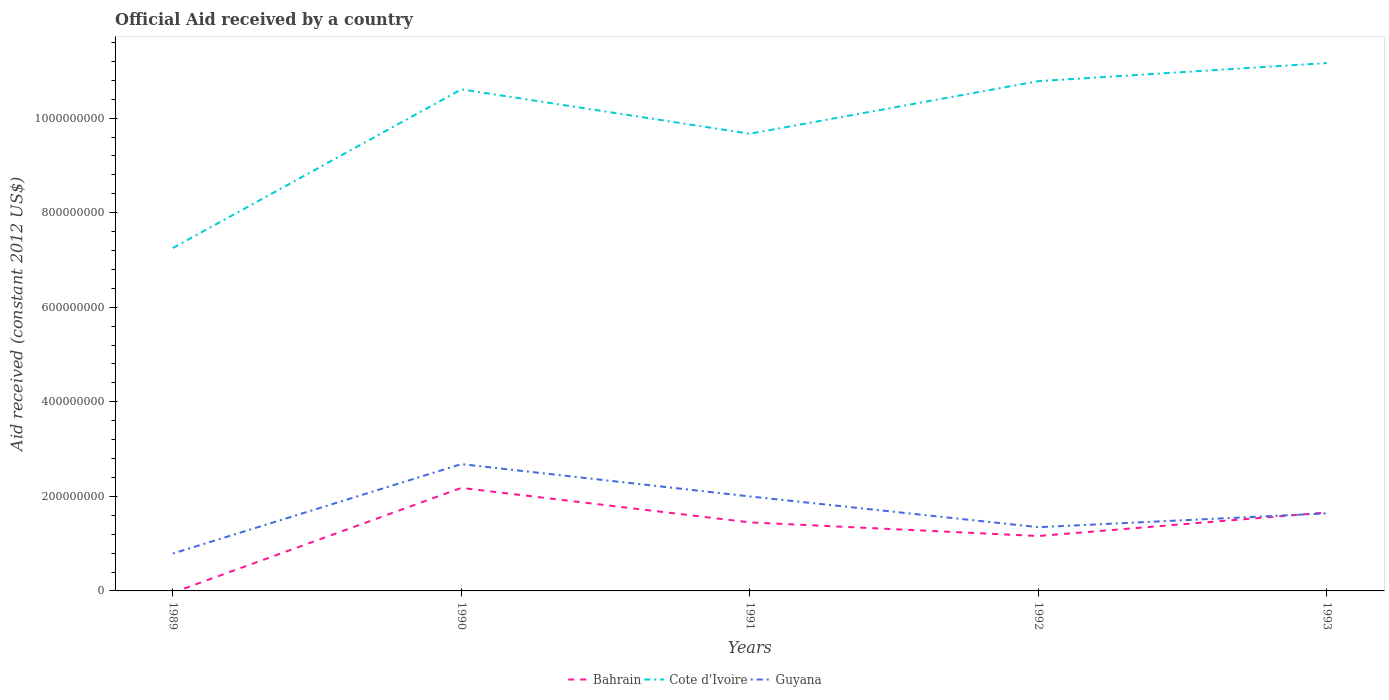How many different coloured lines are there?
Make the answer very short. 3. What is the total net official aid received in Cote d'Ivoire in the graph?
Your answer should be very brief. -5.56e+07. What is the difference between the highest and the second highest net official aid received in Cote d'Ivoire?
Offer a terse response. 3.91e+08. What is the difference between the highest and the lowest net official aid received in Cote d'Ivoire?
Keep it short and to the point. 3. How many years are there in the graph?
Provide a short and direct response. 5. Does the graph contain any zero values?
Offer a terse response. Yes. Where does the legend appear in the graph?
Your answer should be compact. Bottom center. How many legend labels are there?
Your answer should be very brief. 3. What is the title of the graph?
Your answer should be compact. Official Aid received by a country. What is the label or title of the X-axis?
Your answer should be compact. Years. What is the label or title of the Y-axis?
Your answer should be compact. Aid received (constant 2012 US$). What is the Aid received (constant 2012 US$) in Cote d'Ivoire in 1989?
Your answer should be very brief. 7.25e+08. What is the Aid received (constant 2012 US$) in Guyana in 1989?
Your answer should be very brief. 7.91e+07. What is the Aid received (constant 2012 US$) in Bahrain in 1990?
Keep it short and to the point. 2.18e+08. What is the Aid received (constant 2012 US$) in Cote d'Ivoire in 1990?
Your answer should be very brief. 1.06e+09. What is the Aid received (constant 2012 US$) of Guyana in 1990?
Give a very brief answer. 2.68e+08. What is the Aid received (constant 2012 US$) of Bahrain in 1991?
Offer a very short reply. 1.45e+08. What is the Aid received (constant 2012 US$) of Cote d'Ivoire in 1991?
Keep it short and to the point. 9.67e+08. What is the Aid received (constant 2012 US$) in Guyana in 1991?
Your response must be concise. 2.00e+08. What is the Aid received (constant 2012 US$) in Bahrain in 1992?
Provide a succinct answer. 1.16e+08. What is the Aid received (constant 2012 US$) of Cote d'Ivoire in 1992?
Keep it short and to the point. 1.08e+09. What is the Aid received (constant 2012 US$) of Guyana in 1992?
Your answer should be compact. 1.35e+08. What is the Aid received (constant 2012 US$) in Bahrain in 1993?
Offer a very short reply. 1.66e+08. What is the Aid received (constant 2012 US$) of Cote d'Ivoire in 1993?
Ensure brevity in your answer.  1.12e+09. What is the Aid received (constant 2012 US$) of Guyana in 1993?
Keep it short and to the point. 1.64e+08. Across all years, what is the maximum Aid received (constant 2012 US$) in Bahrain?
Provide a succinct answer. 2.18e+08. Across all years, what is the maximum Aid received (constant 2012 US$) of Cote d'Ivoire?
Offer a terse response. 1.12e+09. Across all years, what is the maximum Aid received (constant 2012 US$) of Guyana?
Provide a succinct answer. 2.68e+08. Across all years, what is the minimum Aid received (constant 2012 US$) in Cote d'Ivoire?
Your response must be concise. 7.25e+08. Across all years, what is the minimum Aid received (constant 2012 US$) in Guyana?
Offer a very short reply. 7.91e+07. What is the total Aid received (constant 2012 US$) of Bahrain in the graph?
Offer a terse response. 6.45e+08. What is the total Aid received (constant 2012 US$) of Cote d'Ivoire in the graph?
Provide a short and direct response. 4.95e+09. What is the total Aid received (constant 2012 US$) of Guyana in the graph?
Provide a short and direct response. 8.46e+08. What is the difference between the Aid received (constant 2012 US$) in Cote d'Ivoire in 1989 and that in 1990?
Give a very brief answer. -3.36e+08. What is the difference between the Aid received (constant 2012 US$) of Guyana in 1989 and that in 1990?
Keep it short and to the point. -1.89e+08. What is the difference between the Aid received (constant 2012 US$) of Cote d'Ivoire in 1989 and that in 1991?
Offer a very short reply. -2.42e+08. What is the difference between the Aid received (constant 2012 US$) of Guyana in 1989 and that in 1991?
Your response must be concise. -1.21e+08. What is the difference between the Aid received (constant 2012 US$) of Cote d'Ivoire in 1989 and that in 1992?
Your response must be concise. -3.53e+08. What is the difference between the Aid received (constant 2012 US$) in Guyana in 1989 and that in 1992?
Your response must be concise. -5.57e+07. What is the difference between the Aid received (constant 2012 US$) in Cote d'Ivoire in 1989 and that in 1993?
Provide a short and direct response. -3.91e+08. What is the difference between the Aid received (constant 2012 US$) of Guyana in 1989 and that in 1993?
Your answer should be compact. -8.49e+07. What is the difference between the Aid received (constant 2012 US$) in Bahrain in 1990 and that in 1991?
Offer a terse response. 7.29e+07. What is the difference between the Aid received (constant 2012 US$) of Cote d'Ivoire in 1990 and that in 1991?
Make the answer very short. 9.38e+07. What is the difference between the Aid received (constant 2012 US$) in Guyana in 1990 and that in 1991?
Your response must be concise. 6.84e+07. What is the difference between the Aid received (constant 2012 US$) in Bahrain in 1990 and that in 1992?
Your answer should be very brief. 1.02e+08. What is the difference between the Aid received (constant 2012 US$) of Cote d'Ivoire in 1990 and that in 1992?
Your response must be concise. -1.74e+07. What is the difference between the Aid received (constant 2012 US$) in Guyana in 1990 and that in 1992?
Your answer should be very brief. 1.33e+08. What is the difference between the Aid received (constant 2012 US$) in Bahrain in 1990 and that in 1993?
Ensure brevity in your answer.  5.20e+07. What is the difference between the Aid received (constant 2012 US$) in Cote d'Ivoire in 1990 and that in 1993?
Make the answer very short. -5.56e+07. What is the difference between the Aid received (constant 2012 US$) of Guyana in 1990 and that in 1993?
Offer a very short reply. 1.04e+08. What is the difference between the Aid received (constant 2012 US$) in Bahrain in 1991 and that in 1992?
Keep it short and to the point. 2.89e+07. What is the difference between the Aid received (constant 2012 US$) in Cote d'Ivoire in 1991 and that in 1992?
Ensure brevity in your answer.  -1.11e+08. What is the difference between the Aid received (constant 2012 US$) in Guyana in 1991 and that in 1992?
Keep it short and to the point. 6.50e+07. What is the difference between the Aid received (constant 2012 US$) of Bahrain in 1991 and that in 1993?
Your answer should be very brief. -2.10e+07. What is the difference between the Aid received (constant 2012 US$) of Cote d'Ivoire in 1991 and that in 1993?
Make the answer very short. -1.49e+08. What is the difference between the Aid received (constant 2012 US$) of Guyana in 1991 and that in 1993?
Make the answer very short. 3.58e+07. What is the difference between the Aid received (constant 2012 US$) of Bahrain in 1992 and that in 1993?
Make the answer very short. -4.98e+07. What is the difference between the Aid received (constant 2012 US$) of Cote d'Ivoire in 1992 and that in 1993?
Your answer should be very brief. -3.83e+07. What is the difference between the Aid received (constant 2012 US$) in Guyana in 1992 and that in 1993?
Your answer should be compact. -2.92e+07. What is the difference between the Aid received (constant 2012 US$) of Cote d'Ivoire in 1989 and the Aid received (constant 2012 US$) of Guyana in 1990?
Give a very brief answer. 4.57e+08. What is the difference between the Aid received (constant 2012 US$) in Cote d'Ivoire in 1989 and the Aid received (constant 2012 US$) in Guyana in 1991?
Your response must be concise. 5.26e+08. What is the difference between the Aid received (constant 2012 US$) of Cote d'Ivoire in 1989 and the Aid received (constant 2012 US$) of Guyana in 1992?
Keep it short and to the point. 5.91e+08. What is the difference between the Aid received (constant 2012 US$) of Cote d'Ivoire in 1989 and the Aid received (constant 2012 US$) of Guyana in 1993?
Give a very brief answer. 5.61e+08. What is the difference between the Aid received (constant 2012 US$) of Bahrain in 1990 and the Aid received (constant 2012 US$) of Cote d'Ivoire in 1991?
Ensure brevity in your answer.  -7.49e+08. What is the difference between the Aid received (constant 2012 US$) in Bahrain in 1990 and the Aid received (constant 2012 US$) in Guyana in 1991?
Ensure brevity in your answer.  1.81e+07. What is the difference between the Aid received (constant 2012 US$) of Cote d'Ivoire in 1990 and the Aid received (constant 2012 US$) of Guyana in 1991?
Give a very brief answer. 8.61e+08. What is the difference between the Aid received (constant 2012 US$) of Bahrain in 1990 and the Aid received (constant 2012 US$) of Cote d'Ivoire in 1992?
Provide a short and direct response. -8.60e+08. What is the difference between the Aid received (constant 2012 US$) in Bahrain in 1990 and the Aid received (constant 2012 US$) in Guyana in 1992?
Your answer should be compact. 8.31e+07. What is the difference between the Aid received (constant 2012 US$) in Cote d'Ivoire in 1990 and the Aid received (constant 2012 US$) in Guyana in 1992?
Give a very brief answer. 9.26e+08. What is the difference between the Aid received (constant 2012 US$) of Bahrain in 1990 and the Aid received (constant 2012 US$) of Cote d'Ivoire in 1993?
Provide a short and direct response. -8.99e+08. What is the difference between the Aid received (constant 2012 US$) in Bahrain in 1990 and the Aid received (constant 2012 US$) in Guyana in 1993?
Your response must be concise. 5.38e+07. What is the difference between the Aid received (constant 2012 US$) in Cote d'Ivoire in 1990 and the Aid received (constant 2012 US$) in Guyana in 1993?
Offer a terse response. 8.97e+08. What is the difference between the Aid received (constant 2012 US$) in Bahrain in 1991 and the Aid received (constant 2012 US$) in Cote d'Ivoire in 1992?
Offer a terse response. -9.33e+08. What is the difference between the Aid received (constant 2012 US$) of Bahrain in 1991 and the Aid received (constant 2012 US$) of Guyana in 1992?
Ensure brevity in your answer.  1.02e+07. What is the difference between the Aid received (constant 2012 US$) in Cote d'Ivoire in 1991 and the Aid received (constant 2012 US$) in Guyana in 1992?
Your answer should be very brief. 8.32e+08. What is the difference between the Aid received (constant 2012 US$) in Bahrain in 1991 and the Aid received (constant 2012 US$) in Cote d'Ivoire in 1993?
Provide a short and direct response. -9.72e+08. What is the difference between the Aid received (constant 2012 US$) in Bahrain in 1991 and the Aid received (constant 2012 US$) in Guyana in 1993?
Offer a terse response. -1.90e+07. What is the difference between the Aid received (constant 2012 US$) of Cote d'Ivoire in 1991 and the Aid received (constant 2012 US$) of Guyana in 1993?
Provide a short and direct response. 8.03e+08. What is the difference between the Aid received (constant 2012 US$) of Bahrain in 1992 and the Aid received (constant 2012 US$) of Cote d'Ivoire in 1993?
Offer a very short reply. -1.00e+09. What is the difference between the Aid received (constant 2012 US$) in Bahrain in 1992 and the Aid received (constant 2012 US$) in Guyana in 1993?
Offer a very short reply. -4.79e+07. What is the difference between the Aid received (constant 2012 US$) of Cote d'Ivoire in 1992 and the Aid received (constant 2012 US$) of Guyana in 1993?
Keep it short and to the point. 9.14e+08. What is the average Aid received (constant 2012 US$) in Bahrain per year?
Provide a succinct answer. 1.29e+08. What is the average Aid received (constant 2012 US$) of Cote d'Ivoire per year?
Your answer should be compact. 9.90e+08. What is the average Aid received (constant 2012 US$) in Guyana per year?
Ensure brevity in your answer.  1.69e+08. In the year 1989, what is the difference between the Aid received (constant 2012 US$) in Cote d'Ivoire and Aid received (constant 2012 US$) in Guyana?
Your answer should be very brief. 6.46e+08. In the year 1990, what is the difference between the Aid received (constant 2012 US$) in Bahrain and Aid received (constant 2012 US$) in Cote d'Ivoire?
Keep it short and to the point. -8.43e+08. In the year 1990, what is the difference between the Aid received (constant 2012 US$) of Bahrain and Aid received (constant 2012 US$) of Guyana?
Keep it short and to the point. -5.03e+07. In the year 1990, what is the difference between the Aid received (constant 2012 US$) in Cote d'Ivoire and Aid received (constant 2012 US$) in Guyana?
Your response must be concise. 7.93e+08. In the year 1991, what is the difference between the Aid received (constant 2012 US$) in Bahrain and Aid received (constant 2012 US$) in Cote d'Ivoire?
Your answer should be very brief. -8.22e+08. In the year 1991, what is the difference between the Aid received (constant 2012 US$) in Bahrain and Aid received (constant 2012 US$) in Guyana?
Your response must be concise. -5.48e+07. In the year 1991, what is the difference between the Aid received (constant 2012 US$) in Cote d'Ivoire and Aid received (constant 2012 US$) in Guyana?
Give a very brief answer. 7.67e+08. In the year 1992, what is the difference between the Aid received (constant 2012 US$) in Bahrain and Aid received (constant 2012 US$) in Cote d'Ivoire?
Ensure brevity in your answer.  -9.62e+08. In the year 1992, what is the difference between the Aid received (constant 2012 US$) in Bahrain and Aid received (constant 2012 US$) in Guyana?
Your answer should be compact. -1.87e+07. In the year 1992, what is the difference between the Aid received (constant 2012 US$) of Cote d'Ivoire and Aid received (constant 2012 US$) of Guyana?
Provide a succinct answer. 9.43e+08. In the year 1993, what is the difference between the Aid received (constant 2012 US$) in Bahrain and Aid received (constant 2012 US$) in Cote d'Ivoire?
Make the answer very short. -9.51e+08. In the year 1993, what is the difference between the Aid received (constant 2012 US$) in Bahrain and Aid received (constant 2012 US$) in Guyana?
Make the answer very short. 1.90e+06. In the year 1993, what is the difference between the Aid received (constant 2012 US$) of Cote d'Ivoire and Aid received (constant 2012 US$) of Guyana?
Keep it short and to the point. 9.52e+08. What is the ratio of the Aid received (constant 2012 US$) of Cote d'Ivoire in 1989 to that in 1990?
Offer a very short reply. 0.68. What is the ratio of the Aid received (constant 2012 US$) of Guyana in 1989 to that in 1990?
Your response must be concise. 0.29. What is the ratio of the Aid received (constant 2012 US$) in Cote d'Ivoire in 1989 to that in 1991?
Provide a succinct answer. 0.75. What is the ratio of the Aid received (constant 2012 US$) in Guyana in 1989 to that in 1991?
Offer a terse response. 0.4. What is the ratio of the Aid received (constant 2012 US$) in Cote d'Ivoire in 1989 to that in 1992?
Your answer should be very brief. 0.67. What is the ratio of the Aid received (constant 2012 US$) of Guyana in 1989 to that in 1992?
Ensure brevity in your answer.  0.59. What is the ratio of the Aid received (constant 2012 US$) of Cote d'Ivoire in 1989 to that in 1993?
Provide a succinct answer. 0.65. What is the ratio of the Aid received (constant 2012 US$) in Guyana in 1989 to that in 1993?
Ensure brevity in your answer.  0.48. What is the ratio of the Aid received (constant 2012 US$) of Bahrain in 1990 to that in 1991?
Ensure brevity in your answer.  1.5. What is the ratio of the Aid received (constant 2012 US$) of Cote d'Ivoire in 1990 to that in 1991?
Your answer should be compact. 1.1. What is the ratio of the Aid received (constant 2012 US$) in Guyana in 1990 to that in 1991?
Give a very brief answer. 1.34. What is the ratio of the Aid received (constant 2012 US$) of Bahrain in 1990 to that in 1992?
Your answer should be compact. 1.88. What is the ratio of the Aid received (constant 2012 US$) in Cote d'Ivoire in 1990 to that in 1992?
Your answer should be very brief. 0.98. What is the ratio of the Aid received (constant 2012 US$) of Guyana in 1990 to that in 1992?
Provide a succinct answer. 1.99. What is the ratio of the Aid received (constant 2012 US$) in Bahrain in 1990 to that in 1993?
Make the answer very short. 1.31. What is the ratio of the Aid received (constant 2012 US$) of Cote d'Ivoire in 1990 to that in 1993?
Your answer should be compact. 0.95. What is the ratio of the Aid received (constant 2012 US$) in Guyana in 1990 to that in 1993?
Offer a terse response. 1.64. What is the ratio of the Aid received (constant 2012 US$) of Bahrain in 1991 to that in 1992?
Your answer should be very brief. 1.25. What is the ratio of the Aid received (constant 2012 US$) of Cote d'Ivoire in 1991 to that in 1992?
Offer a very short reply. 0.9. What is the ratio of the Aid received (constant 2012 US$) of Guyana in 1991 to that in 1992?
Ensure brevity in your answer.  1.48. What is the ratio of the Aid received (constant 2012 US$) in Bahrain in 1991 to that in 1993?
Offer a terse response. 0.87. What is the ratio of the Aid received (constant 2012 US$) in Cote d'Ivoire in 1991 to that in 1993?
Provide a short and direct response. 0.87. What is the ratio of the Aid received (constant 2012 US$) in Guyana in 1991 to that in 1993?
Your answer should be compact. 1.22. What is the ratio of the Aid received (constant 2012 US$) of Bahrain in 1992 to that in 1993?
Your answer should be very brief. 0.7. What is the ratio of the Aid received (constant 2012 US$) of Cote d'Ivoire in 1992 to that in 1993?
Make the answer very short. 0.97. What is the ratio of the Aid received (constant 2012 US$) in Guyana in 1992 to that in 1993?
Provide a succinct answer. 0.82. What is the difference between the highest and the second highest Aid received (constant 2012 US$) of Bahrain?
Your answer should be compact. 5.20e+07. What is the difference between the highest and the second highest Aid received (constant 2012 US$) in Cote d'Ivoire?
Give a very brief answer. 3.83e+07. What is the difference between the highest and the second highest Aid received (constant 2012 US$) of Guyana?
Provide a short and direct response. 6.84e+07. What is the difference between the highest and the lowest Aid received (constant 2012 US$) in Bahrain?
Your answer should be compact. 2.18e+08. What is the difference between the highest and the lowest Aid received (constant 2012 US$) in Cote d'Ivoire?
Provide a succinct answer. 3.91e+08. What is the difference between the highest and the lowest Aid received (constant 2012 US$) in Guyana?
Give a very brief answer. 1.89e+08. 